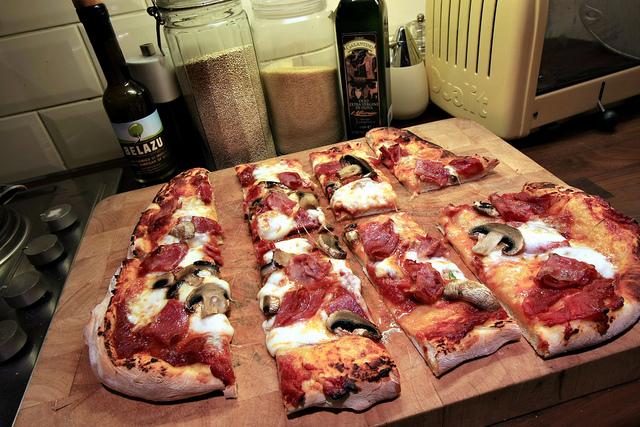Does this pizza have mushrooms?
Write a very short answer. Yes. What shape are the slices?
Short answer required. Rectangle. Is this pizza from Pizza Hut?
Quick response, please. No. 